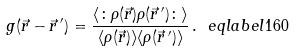Convert formula to latex. <formula><loc_0><loc_0><loc_500><loc_500>g ( \vec { r } - \vec { r } \, ^ { \prime } ) = \frac { \langle \colon \rho ( \vec { r } ) \rho ( \vec { r } \, ^ { \prime } ) \colon \rangle } { \langle \rho ( \vec { r } ) \rangle \langle \rho ( \vec { r } \, ^ { \prime } ) \rangle } \, . \ e q l a b e l { 1 6 0 }</formula> 